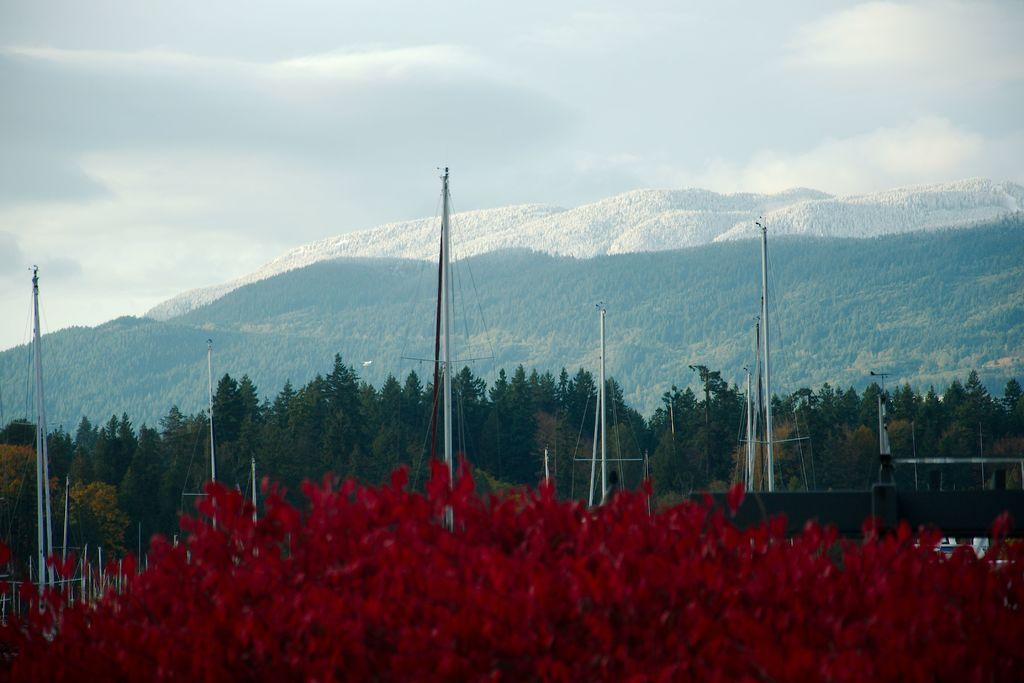What type of plants are in the image? There are flowers in the image. What color are the flowers? The flowers are red. What can be seen in the background of the image? There are poles, trees, and mountains in the background of the image. What color are the trees? The trees are green. What is the color of the sky in the image? The sky is white in the image. Who is the servant cooking in the image? There is no servant or cooking activity present in the image. What type of clouds can be seen in the image? There are no clouds visible in the image, as the sky is white. 